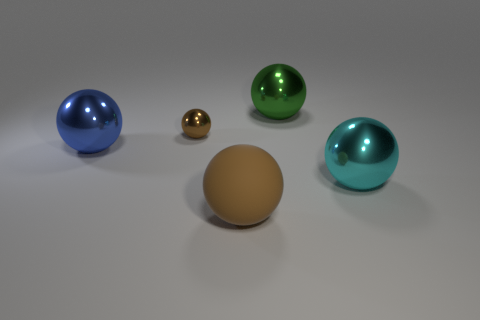How many brown spheres must be subtracted to get 1 brown spheres? 1 Subtract all brown metallic balls. How many balls are left? 4 Add 5 gray balls. How many objects exist? 10 Subtract all blue spheres. How many spheres are left? 4 Subtract all cyan balls. Subtract all purple cylinders. How many balls are left? 4 Subtract all cyan blocks. How many gray spheres are left? 0 Subtract all large blue objects. Subtract all brown rubber balls. How many objects are left? 3 Add 3 shiny balls. How many shiny balls are left? 7 Add 2 small purple rubber cylinders. How many small purple rubber cylinders exist? 2 Subtract 2 brown balls. How many objects are left? 3 